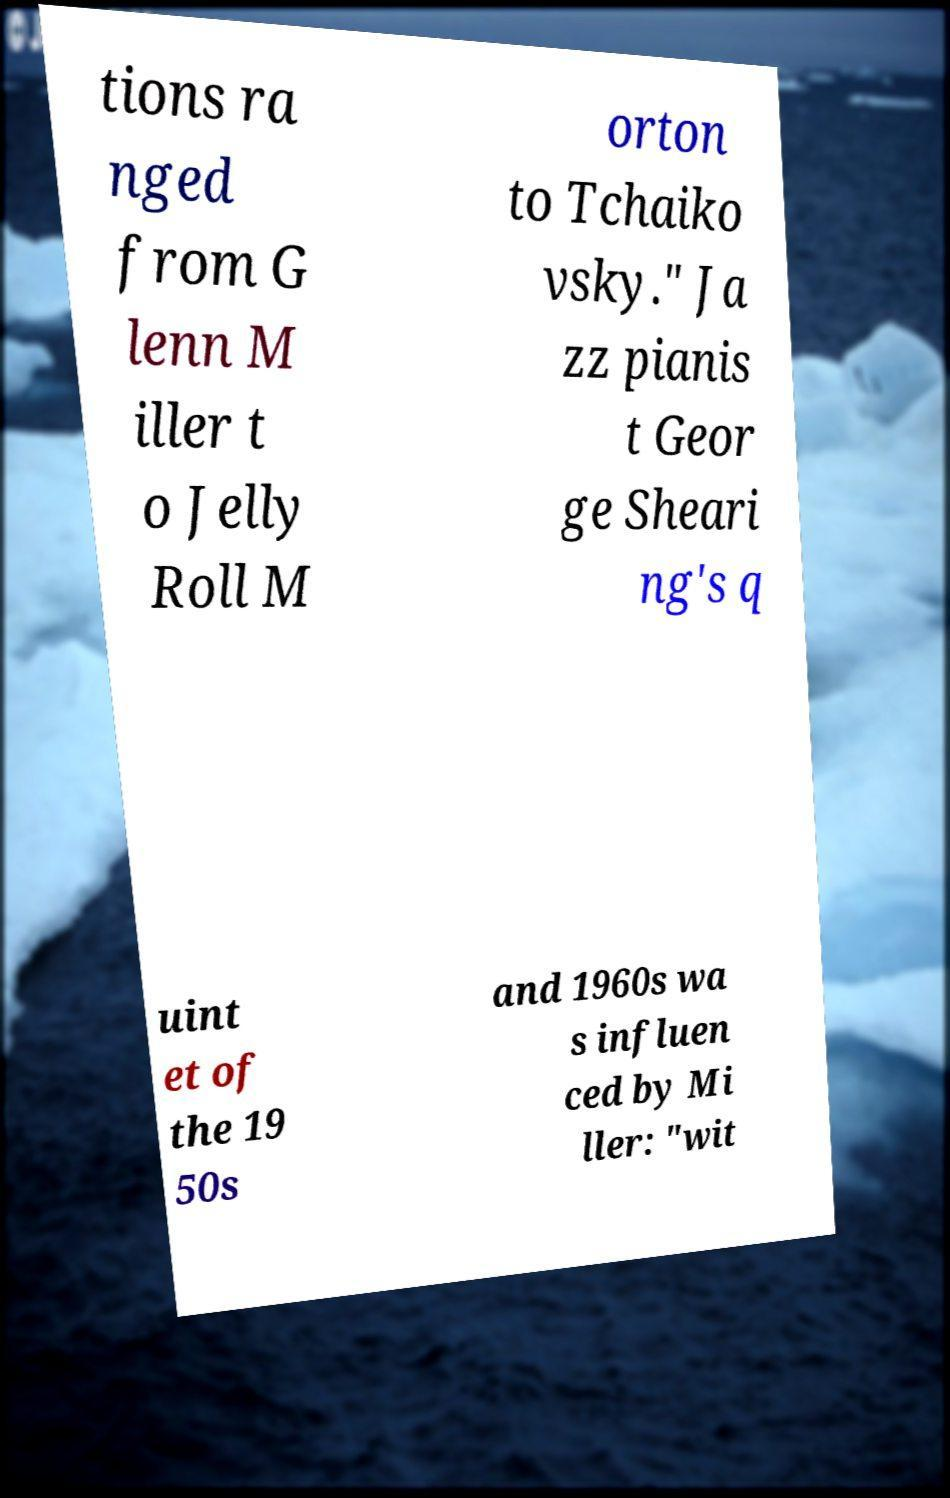What messages or text are displayed in this image? I need them in a readable, typed format. tions ra nged from G lenn M iller t o Jelly Roll M orton to Tchaiko vsky." Ja zz pianis t Geor ge Sheari ng's q uint et of the 19 50s and 1960s wa s influen ced by Mi ller: "wit 